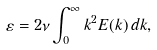Convert formula to latex. <formula><loc_0><loc_0><loc_500><loc_500>\varepsilon = 2 \nu \int _ { 0 } ^ { \infty } k ^ { 2 } E ( k ) \, d k ,</formula> 